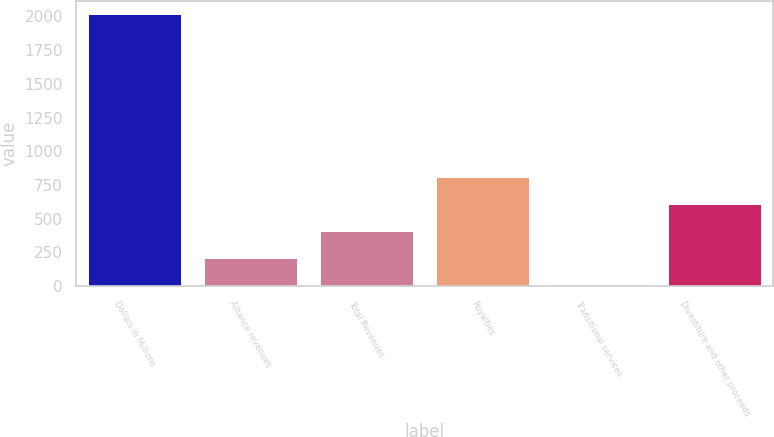Convert chart to OTSL. <chart><loc_0><loc_0><loc_500><loc_500><bar_chart><fcel>Dollars in Millions<fcel>Alliance revenues<fcel>Total Revenues<fcel>Royalties<fcel>Transitional services<fcel>Divestiture and other proceeds<nl><fcel>2016<fcel>207.9<fcel>408.8<fcel>810.6<fcel>7<fcel>609.7<nl></chart> 